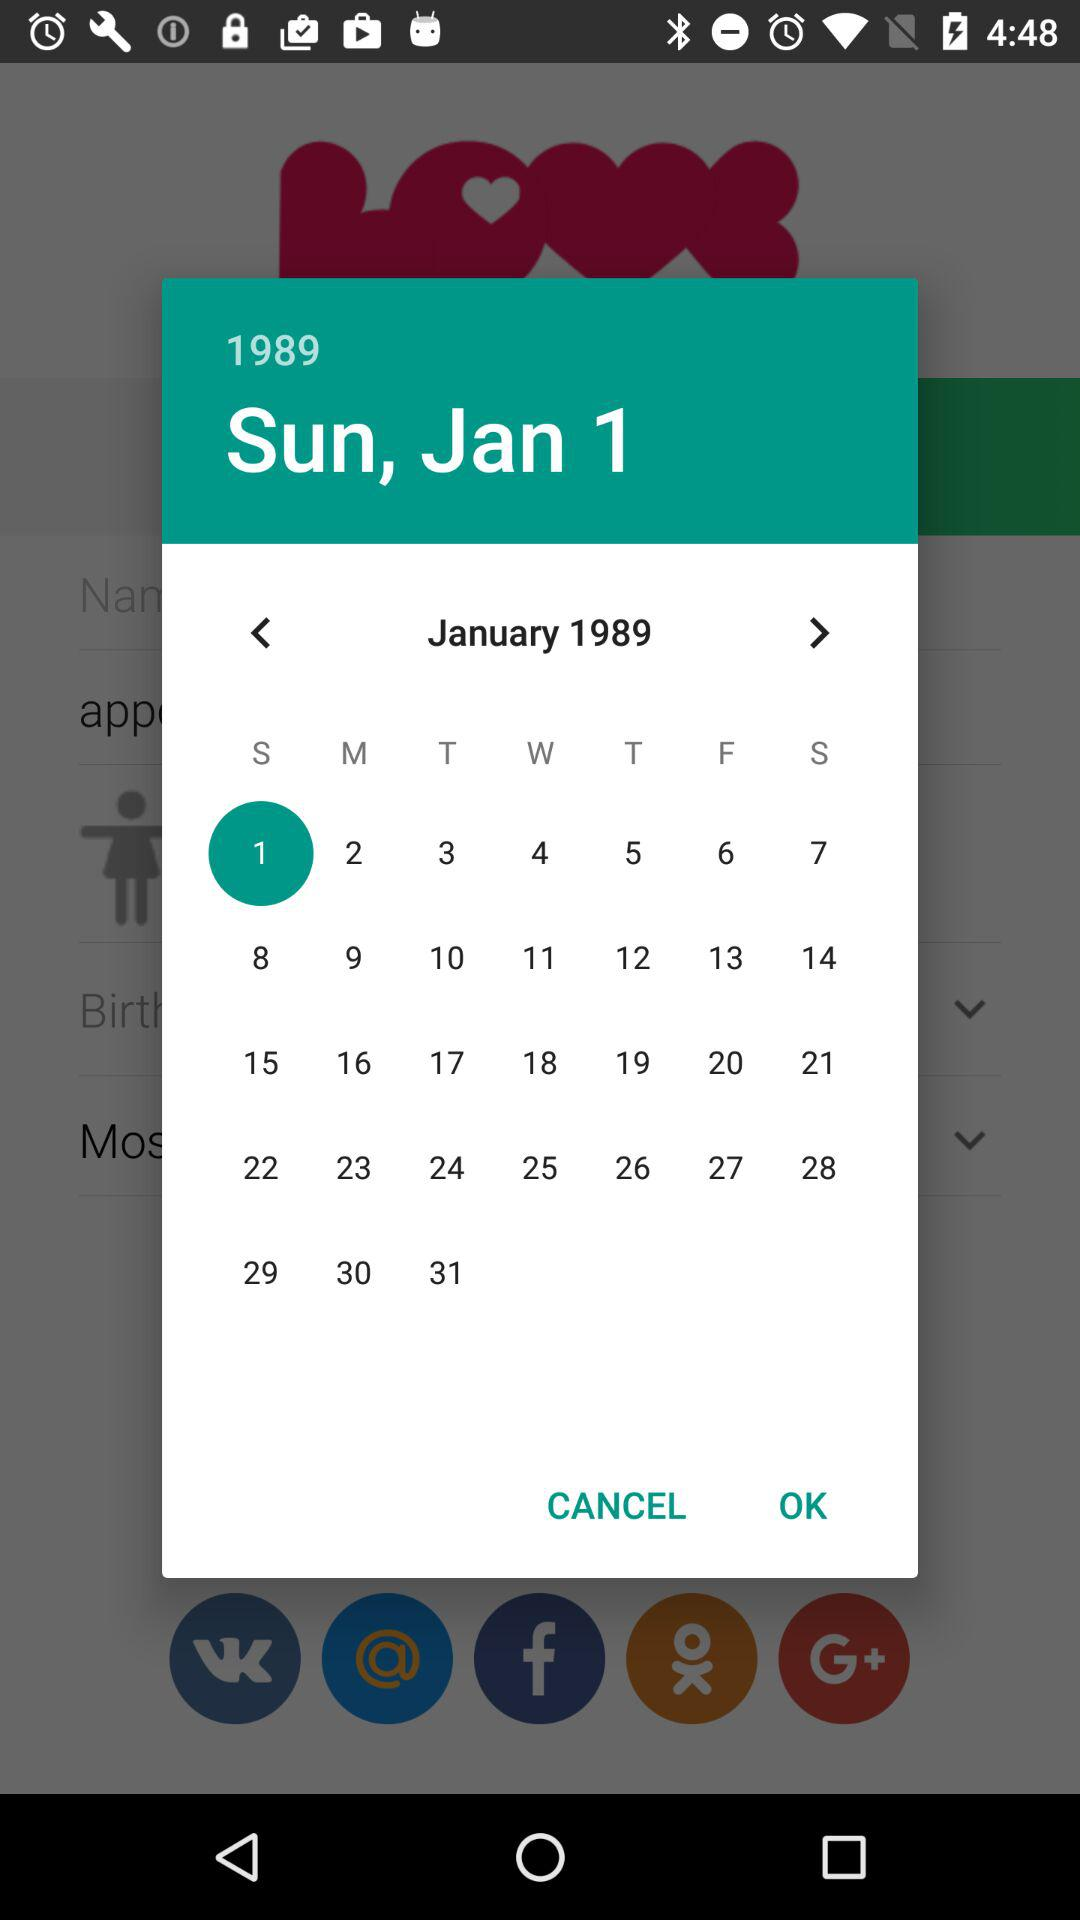What is the date of the first day of the month?
Answer the question using a single word or phrase. Sun, Jan 1 